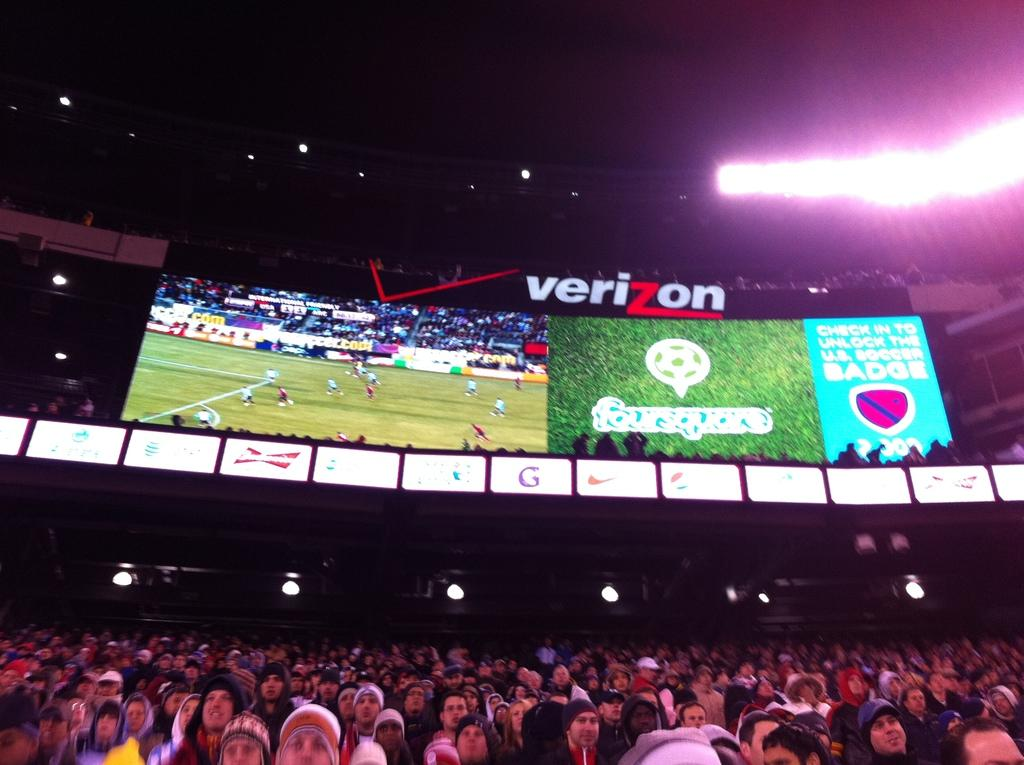Provide a one-sentence caption for the provided image. A stadium of people are sitting under a Verizon scoreboard watching a game. 